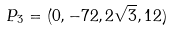<formula> <loc_0><loc_0><loc_500><loc_500>P _ { 3 } = ( 0 , - 7 2 , 2 \sqrt { 3 } , 1 2 )</formula> 